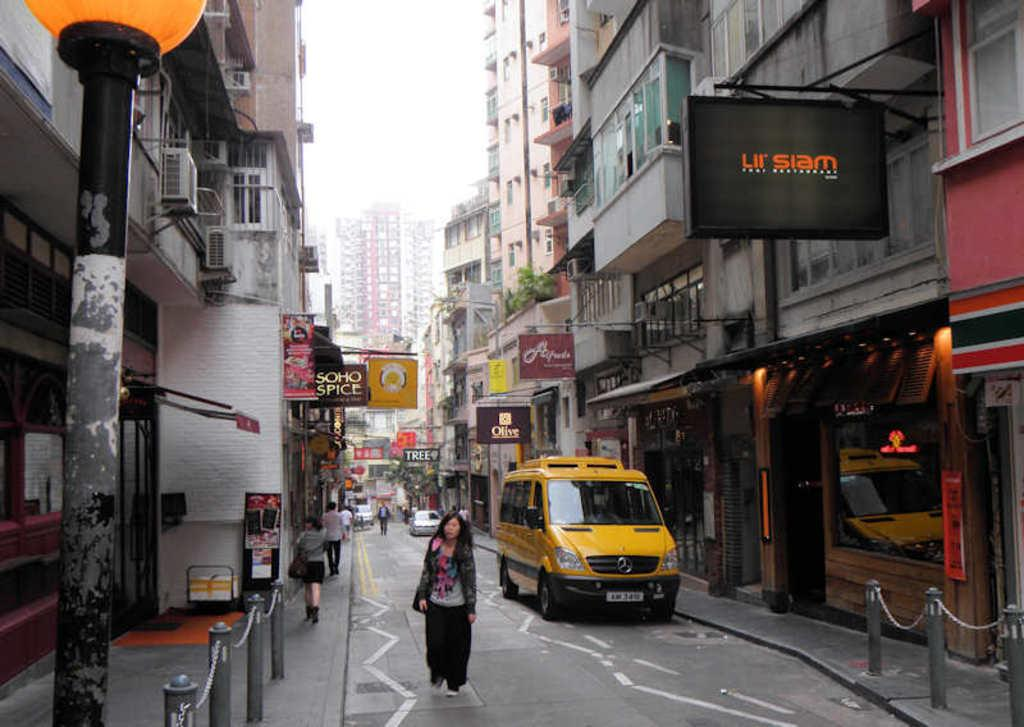Provide a one-sentence caption for the provided image. A yellow van on right side on street near a black LII Siam sign. 